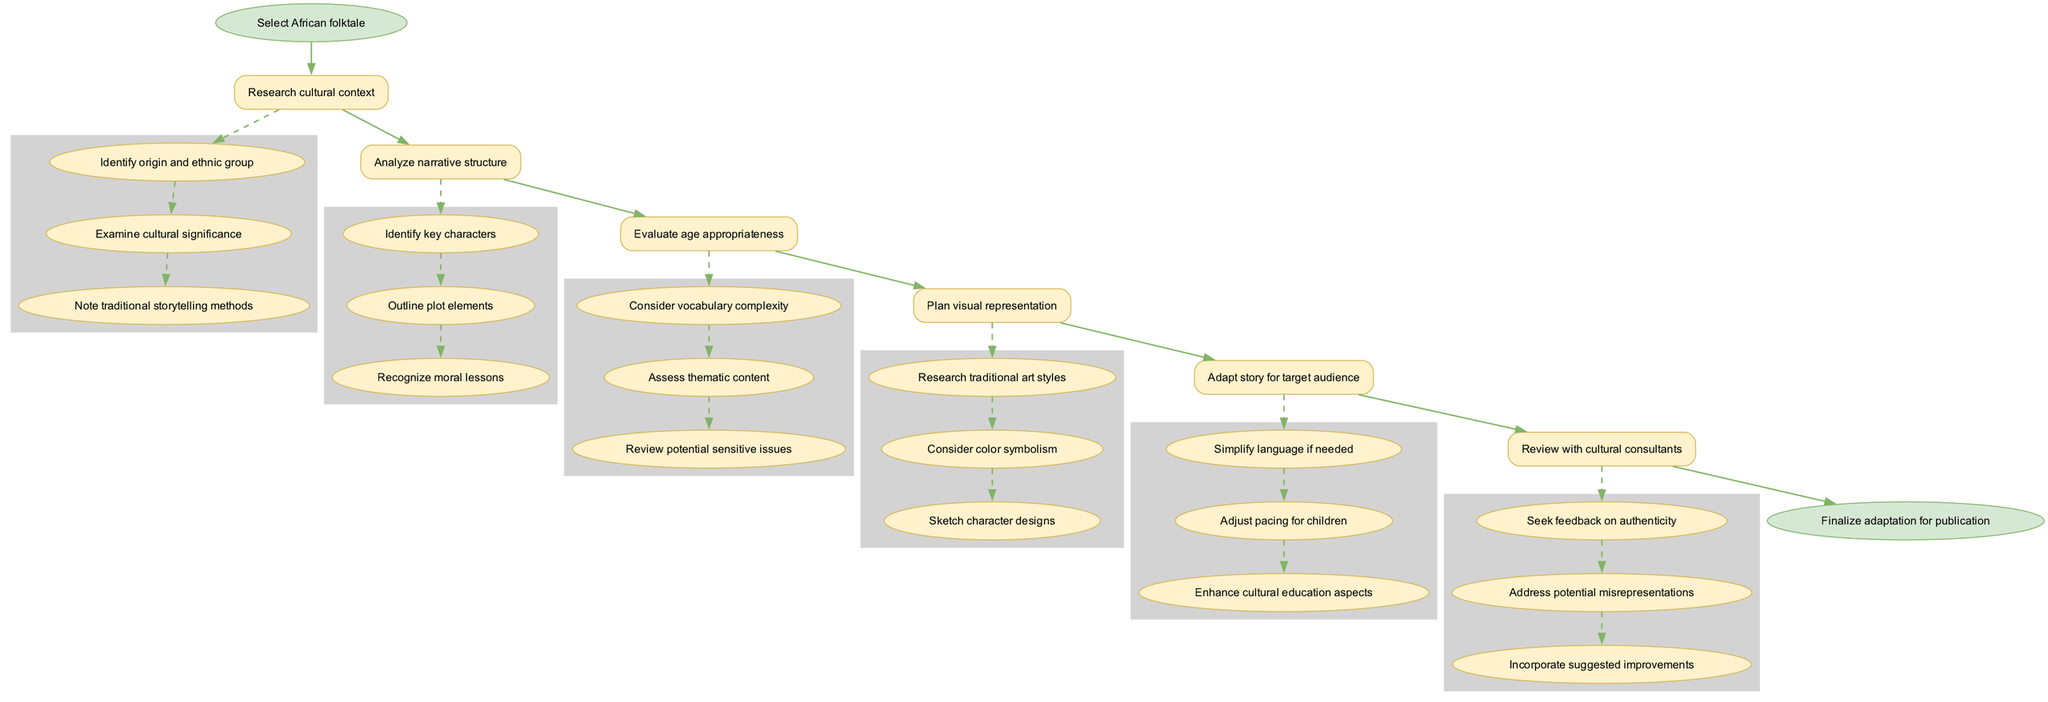What is the first step in the adaptation process? The first step is represented at the top of the flow chart, which indicates the initiation of the process. It explicitly names the action to be taken as the first item in the sequence.
Answer: Select African folktale How many main steps are there in the diagram? By counting the distinct steps listed in the flow chart, it provides an overview of the process. There are six main steps outlined in the sequence before reaching the end.
Answer: 6 What is the last node before finalization? The last main step before reaching the end of the adaptation process can be identified just before the final node. This reveals the step that requires attention before concluding the adaptation.
Answer: Review with cultural consultants Which step includes examining cultural significance? This specific action is found within the substeps of one of the main steps dedicated to researching context about the folktale. It involves diving deeper into understanding the background of the story.
Answer: Research cultural context What action follows "Analyze narrative structure"? Looking at the flowchart, we see the linear progression of steps as denoted by the edges connecting them. By following the direction of the arrows, we can identify the next step.
Answer: Evaluate age appropriateness How many substeps are included in the "Plan visual representation" step? To determine the count, we refer to the main step and examine the substeps listed underneath it. Each corresponds to a specific task contributing to planning the visual aspects.
Answer: 3 Why is "Validate age appropriateness" an essential step in the adaptation process? This step is crucial because it focuses on ensuring that the language and themes align correctly with the intended audience, which is children in this context. It assesses whether the content is suitable for young readers.
Answer: To ensure content suitability for children What type of feedback is sought from cultural consultants? The relationship between the main step and its substeps indicates the focus areas during the feedback process. Each aims to ensure accuracy in representation and address potential issues.
Answer: Feedback on authenticity What does the final node represent? The last node signifies the culmination of all preceding actions in this flow chart, which indicates what happens after all steps are completed. It shows the goal of the entire adaptation process.
Answer: Finalize adaptation for publication 